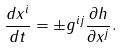<formula> <loc_0><loc_0><loc_500><loc_500>\frac { d x ^ { i } } { d t } = \pm g ^ { i j } \frac { \partial h } { \partial x ^ { j } } .</formula> 